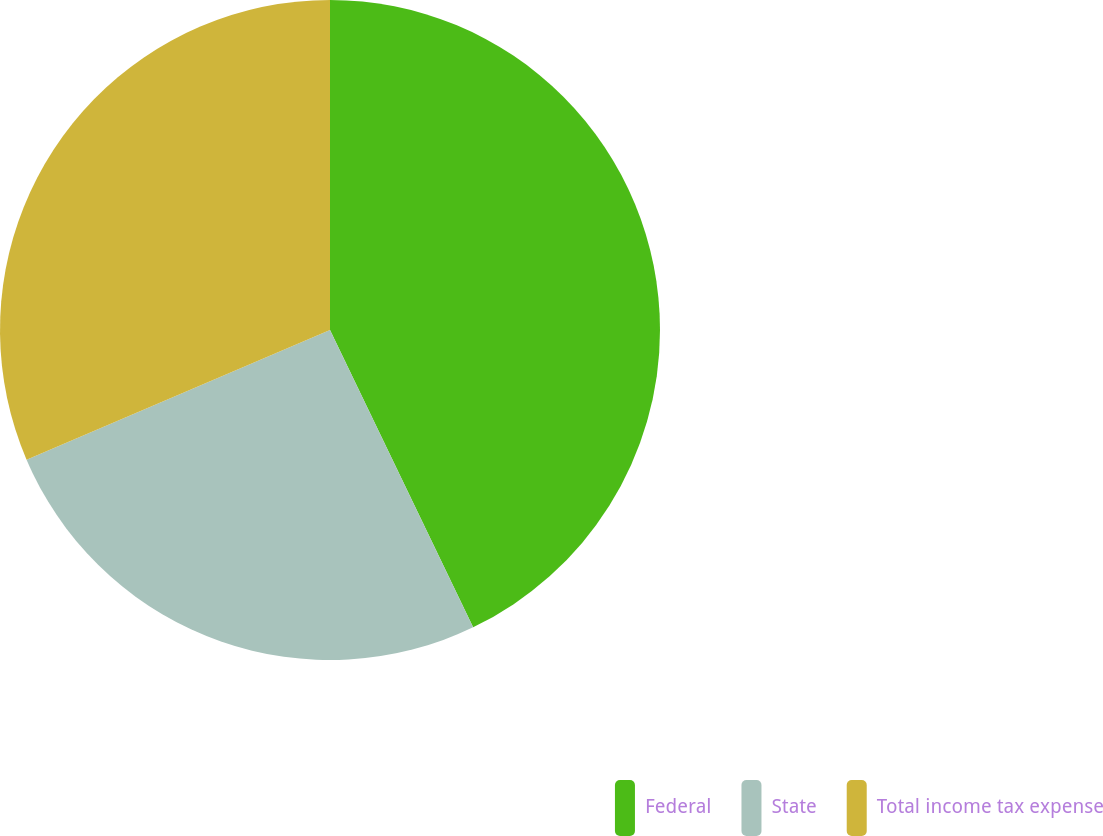<chart> <loc_0><loc_0><loc_500><loc_500><pie_chart><fcel>Federal<fcel>State<fcel>Total income tax expense<nl><fcel>42.86%<fcel>25.71%<fcel>31.43%<nl></chart> 